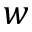Convert formula to latex. <formula><loc_0><loc_0><loc_500><loc_500>w</formula> 